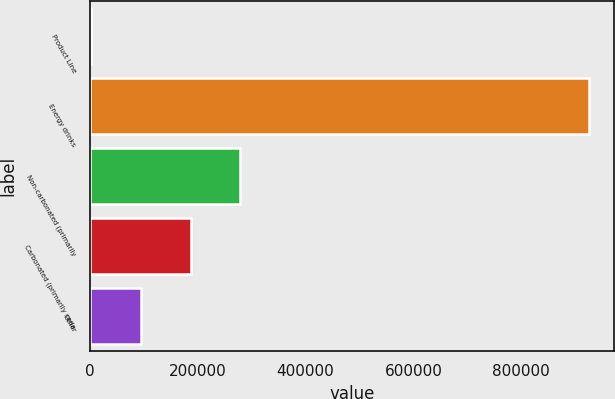<chart> <loc_0><loc_0><loc_500><loc_500><bar_chart><fcel>Product Line<fcel>Energy drinks<fcel>Non-carbonated (primarily<fcel>Carbonated (primarily soda<fcel>Other<nl><fcel>2008<fcel>925398<fcel>279025<fcel>186686<fcel>94347<nl></chart> 